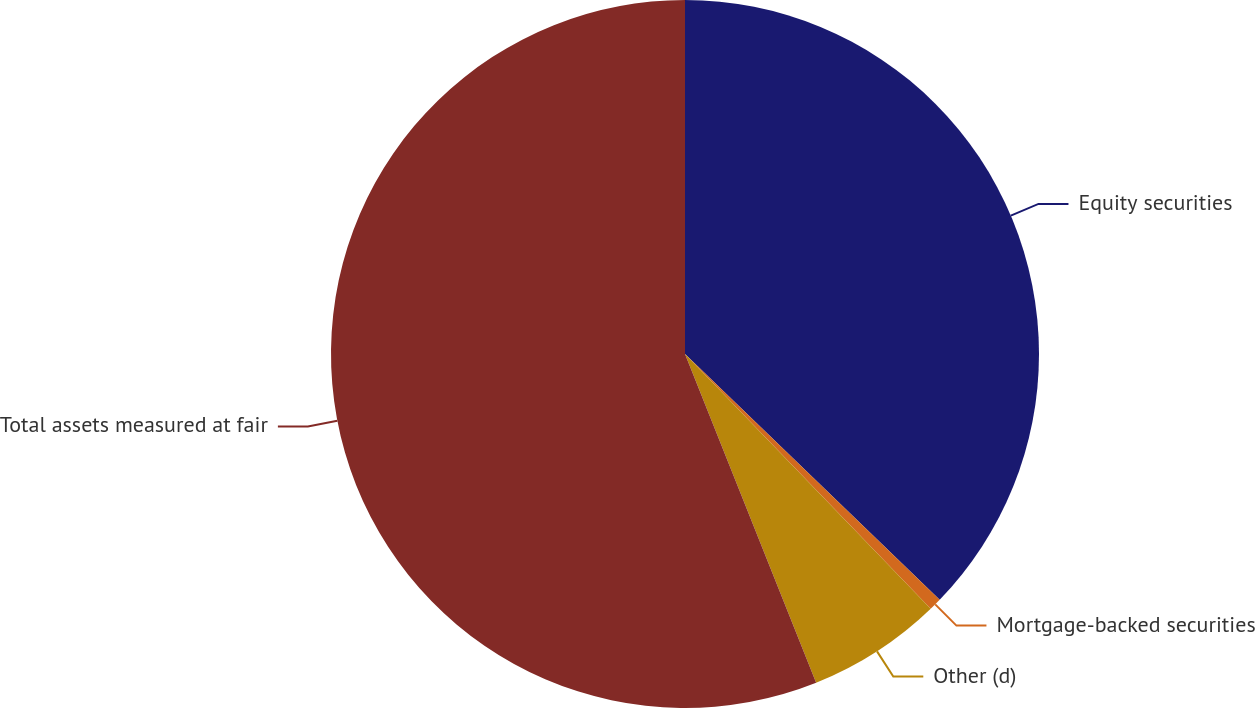<chart> <loc_0><loc_0><loc_500><loc_500><pie_chart><fcel>Equity securities<fcel>Mortgage-backed securities<fcel>Other (d)<fcel>Total assets measured at fair<nl><fcel>37.22%<fcel>0.57%<fcel>6.17%<fcel>56.04%<nl></chart> 